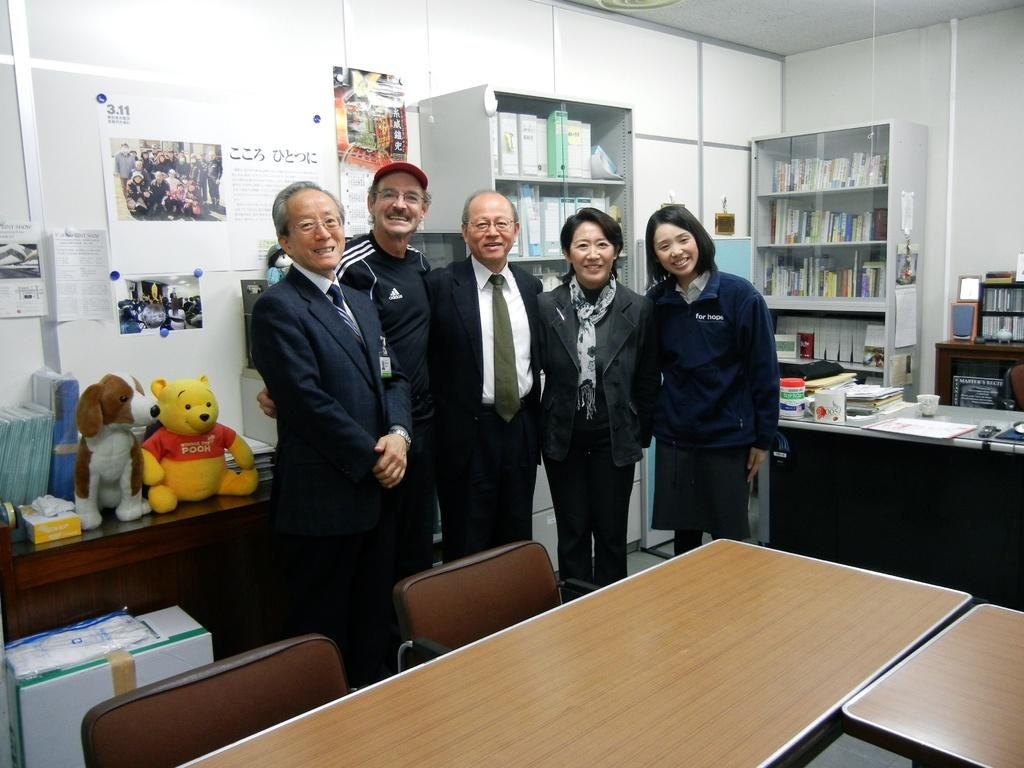How many people are present in the image? There are five people standing in the image. What type of furniture can be seen in the image? There is a table and a chair in the image. What is on the table in the image? There is a cup and books on the table. Where are the books stored when not on the table? There is a book rack in the image, which is likely where the books are stored when not on the table. How much money is being exchanged between the people in the image? There is no indication of money or any exchange of money in the image. What type of root can be seen growing from the chair in the image? There is no root visible in the image, and the chair is not connected to any plant or root. 